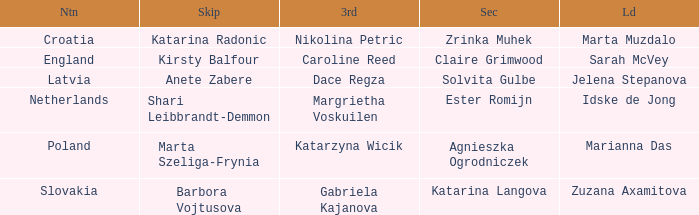What is the name of the third who has Barbora Vojtusova as Skip? Gabriela Kajanova. 